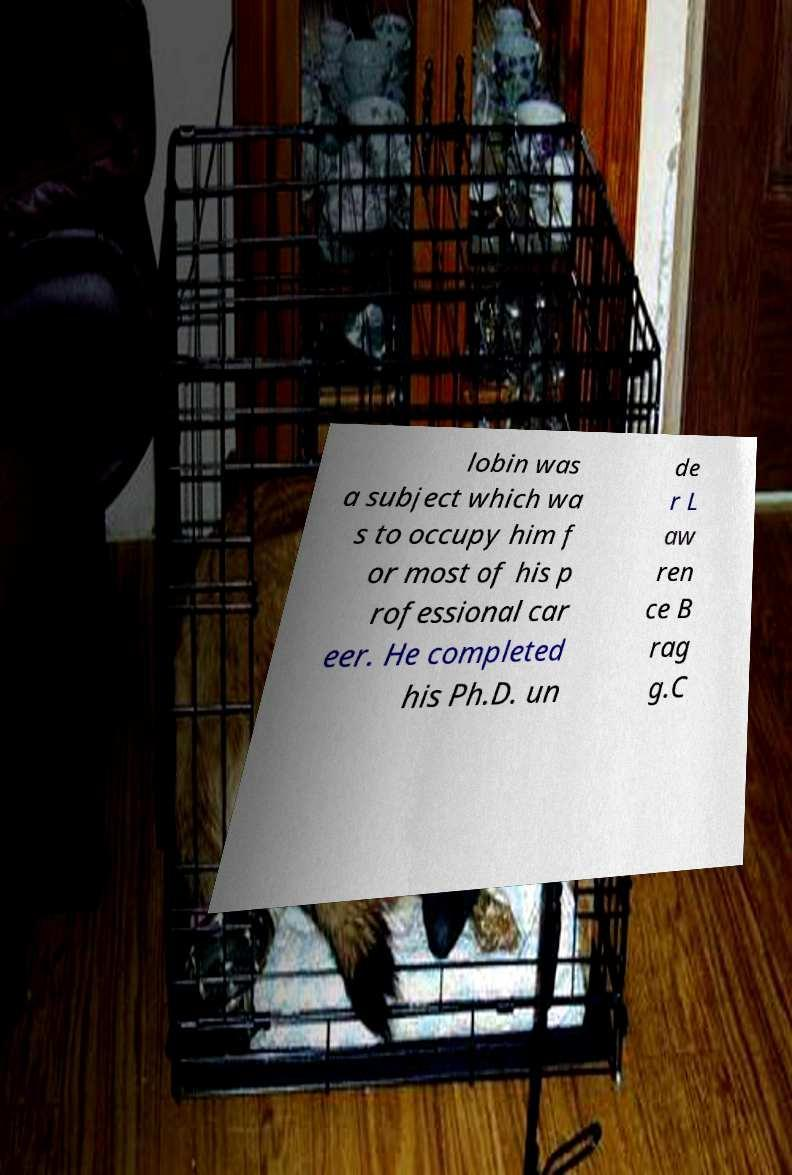I need the written content from this picture converted into text. Can you do that? lobin was a subject which wa s to occupy him f or most of his p rofessional car eer. He completed his Ph.D. un de r L aw ren ce B rag g.C 